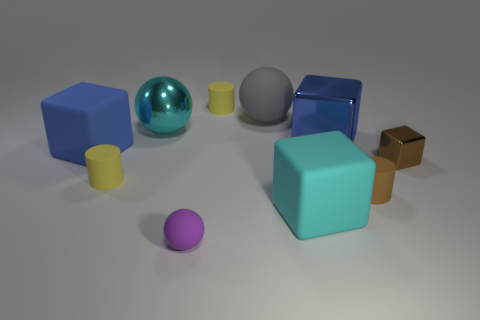How many yellow cylinders must be subtracted to get 1 yellow cylinders? 1 Subtract all balls. How many objects are left? 7 Subtract 2 spheres. How many spheres are left? 1 Subtract all big cyan cubes. How many cubes are left? 3 Subtract all yellow cylinders. Subtract all brown blocks. How many cylinders are left? 1 Subtract all gray balls. How many yellow cylinders are left? 2 Subtract all small cubes. Subtract all small metallic blocks. How many objects are left? 8 Add 6 small brown cubes. How many small brown cubes are left? 7 Add 2 large cyan spheres. How many large cyan spheres exist? 3 Subtract all yellow cylinders. How many cylinders are left? 1 